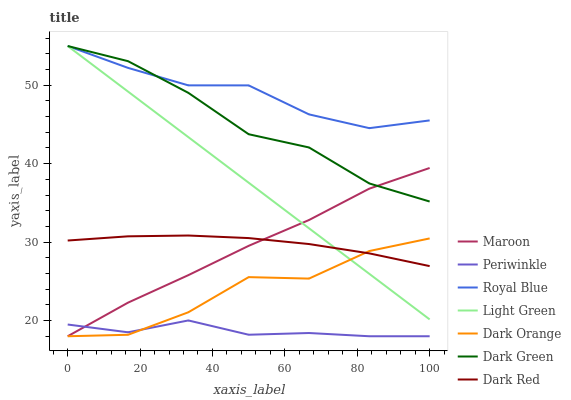Does Periwinkle have the minimum area under the curve?
Answer yes or no. Yes. Does Royal Blue have the maximum area under the curve?
Answer yes or no. Yes. Does Dark Red have the minimum area under the curve?
Answer yes or no. No. Does Dark Red have the maximum area under the curve?
Answer yes or no. No. Is Light Green the smoothest?
Answer yes or no. Yes. Is Dark Orange the roughest?
Answer yes or no. Yes. Is Dark Red the smoothest?
Answer yes or no. No. Is Dark Red the roughest?
Answer yes or no. No. Does Dark Orange have the lowest value?
Answer yes or no. Yes. Does Dark Red have the lowest value?
Answer yes or no. No. Does Dark Green have the highest value?
Answer yes or no. Yes. Does Dark Red have the highest value?
Answer yes or no. No. Is Dark Orange less than Dark Green?
Answer yes or no. Yes. Is Dark Green greater than Dark Orange?
Answer yes or no. Yes. Does Dark Orange intersect Periwinkle?
Answer yes or no. Yes. Is Dark Orange less than Periwinkle?
Answer yes or no. No. Is Dark Orange greater than Periwinkle?
Answer yes or no. No. Does Dark Orange intersect Dark Green?
Answer yes or no. No. 